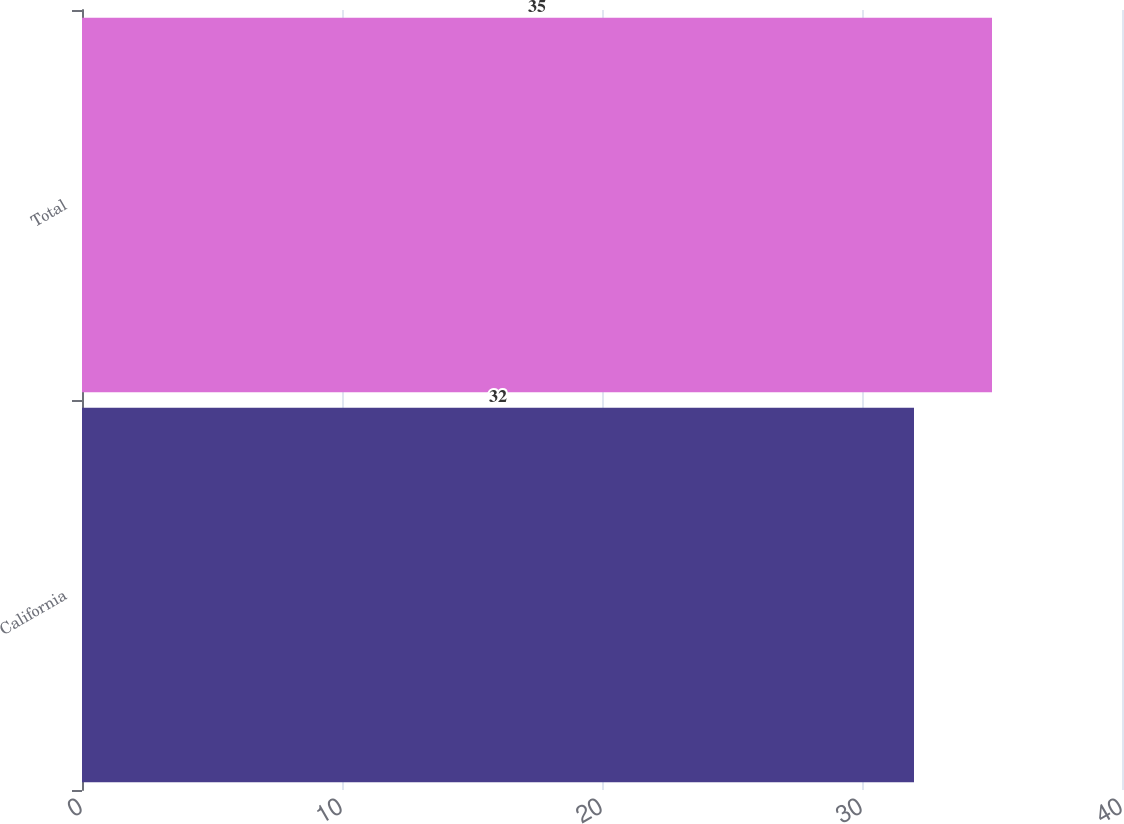Convert chart. <chart><loc_0><loc_0><loc_500><loc_500><bar_chart><fcel>California<fcel>Total<nl><fcel>32<fcel>35<nl></chart> 